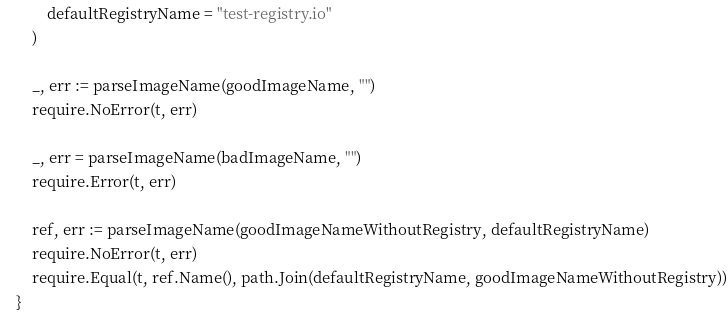<code> <loc_0><loc_0><loc_500><loc_500><_Go_>
		defaultRegistryName = "test-registry.io"
	)

	_, err := parseImageName(goodImageName, "")
	require.NoError(t, err)

	_, err = parseImageName(badImageName, "")
	require.Error(t, err)

	ref, err := parseImageName(goodImageNameWithoutRegistry, defaultRegistryName)
	require.NoError(t, err)
	require.Equal(t, ref.Name(), path.Join(defaultRegistryName, goodImageNameWithoutRegistry))
}
</code> 